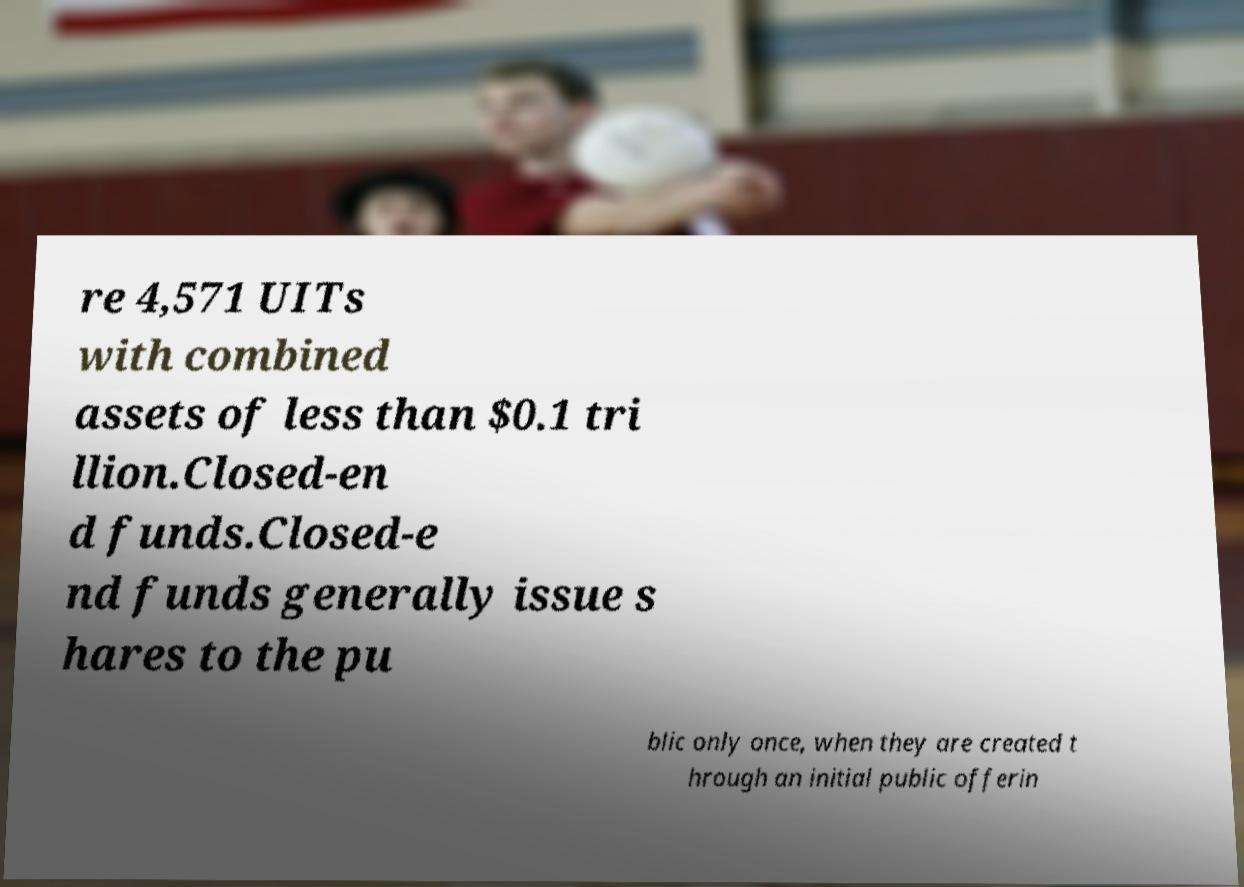Could you extract and type out the text from this image? re 4,571 UITs with combined assets of less than $0.1 tri llion.Closed-en d funds.Closed-e nd funds generally issue s hares to the pu blic only once, when they are created t hrough an initial public offerin 